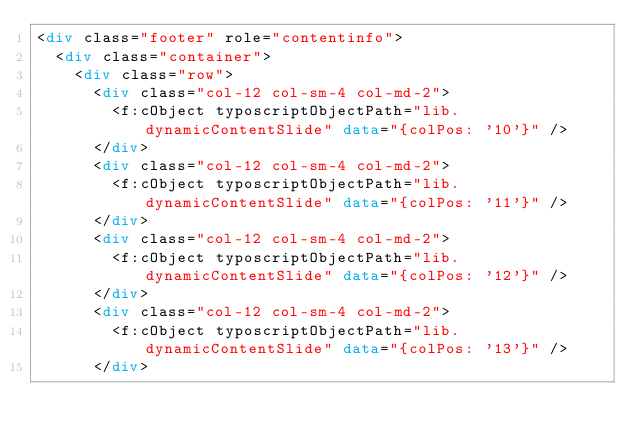Convert code to text. <code><loc_0><loc_0><loc_500><loc_500><_HTML_><div class="footer" role="contentinfo">
	<div class="container">
		<div class="row">
			<div class="col-12 col-sm-4 col-md-2">
				<f:cObject typoscriptObjectPath="lib.dynamicContentSlide" data="{colPos: '10'}" />
			</div>
			<div class="col-12 col-sm-4 col-md-2">
				<f:cObject typoscriptObjectPath="lib.dynamicContentSlide" data="{colPos: '11'}" />
			</div>
			<div class="col-12 col-sm-4 col-md-2">
				<f:cObject typoscriptObjectPath="lib.dynamicContentSlide" data="{colPos: '12'}" />
			</div>
			<div class="col-12 col-sm-4 col-md-2">
				<f:cObject typoscriptObjectPath="lib.dynamicContentSlide" data="{colPos: '13'}" />
			</div></code> 